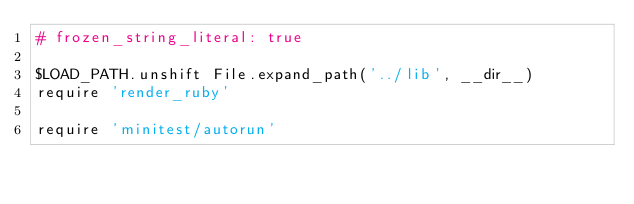<code> <loc_0><loc_0><loc_500><loc_500><_Ruby_># frozen_string_literal: true

$LOAD_PATH.unshift File.expand_path('../lib', __dir__)
require 'render_ruby'

require 'minitest/autorun'
</code> 